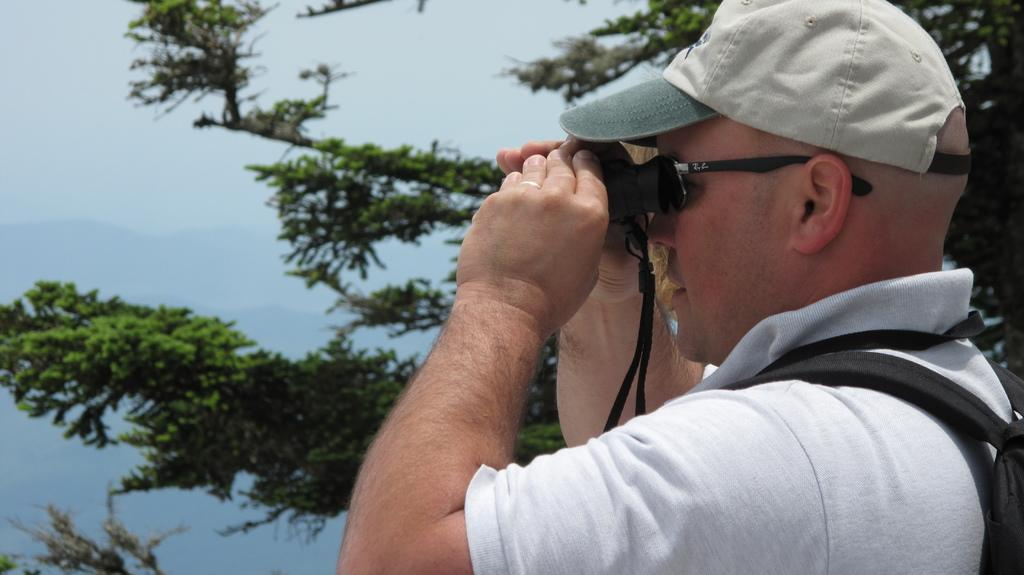What is the main subject of the image? The main subject of the image is a man. What is the man holding in the image? The man is holding binoculars. What type of natural element can be seen in the image? There is a tree in the image. What is visible at the top of the image? The sky is visible in the image. What type of throat problem is the man experiencing in the image? There is no indication in the image that the man is experiencing any throat problems. Can you tell me how many bees are visible on the tree in the image? There are no bees visible on the tree in the image. 